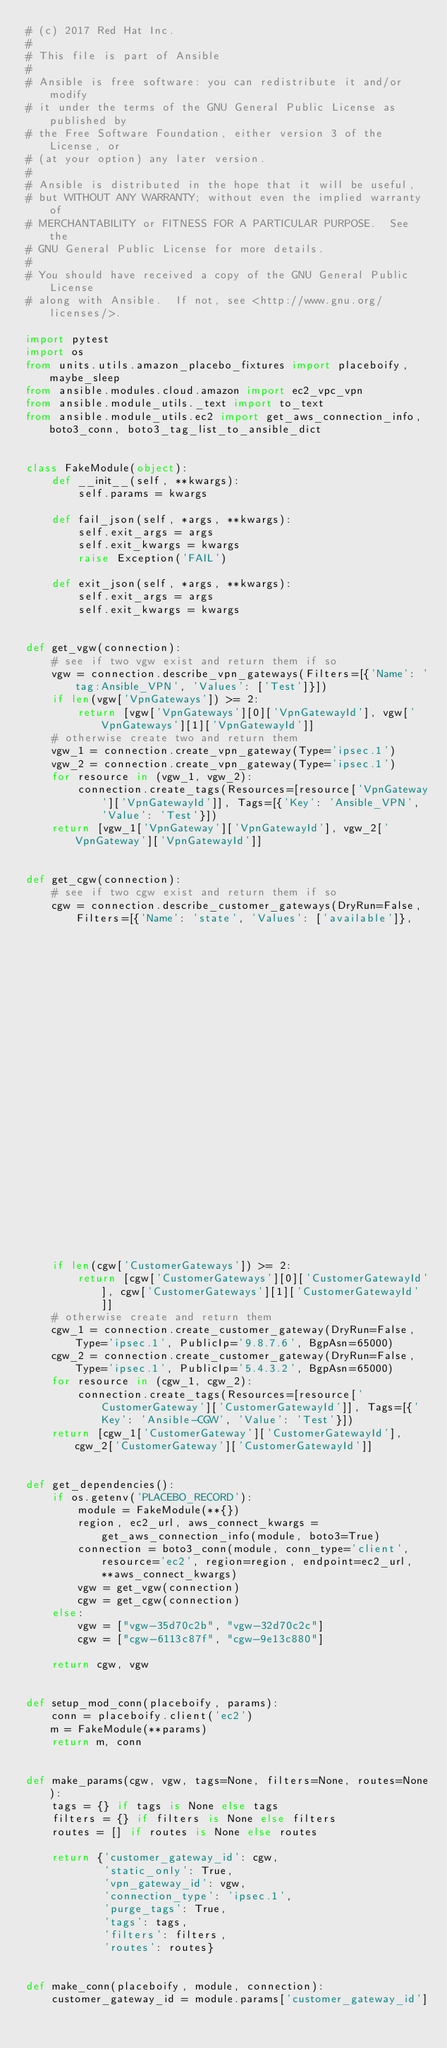Convert code to text. <code><loc_0><loc_0><loc_500><loc_500><_Python_># (c) 2017 Red Hat Inc.
#
# This file is part of Ansible
#
# Ansible is free software: you can redistribute it and/or modify
# it under the terms of the GNU General Public License as published by
# the Free Software Foundation, either version 3 of the License, or
# (at your option) any later version.
#
# Ansible is distributed in the hope that it will be useful,
# but WITHOUT ANY WARRANTY; without even the implied warranty of
# MERCHANTABILITY or FITNESS FOR A PARTICULAR PURPOSE.  See the
# GNU General Public License for more details.
#
# You should have received a copy of the GNU General Public License
# along with Ansible.  If not, see <http://www.gnu.org/licenses/>.

import pytest
import os
from units.utils.amazon_placebo_fixtures import placeboify, maybe_sleep
from ansible.modules.cloud.amazon import ec2_vpc_vpn
from ansible.module_utils._text import to_text
from ansible.module_utils.ec2 import get_aws_connection_info, boto3_conn, boto3_tag_list_to_ansible_dict


class FakeModule(object):
    def __init__(self, **kwargs):
        self.params = kwargs

    def fail_json(self, *args, **kwargs):
        self.exit_args = args
        self.exit_kwargs = kwargs
        raise Exception('FAIL')

    def exit_json(self, *args, **kwargs):
        self.exit_args = args
        self.exit_kwargs = kwargs


def get_vgw(connection):
    # see if two vgw exist and return them if so
    vgw = connection.describe_vpn_gateways(Filters=[{'Name': 'tag:Ansible_VPN', 'Values': ['Test']}])
    if len(vgw['VpnGateways']) >= 2:
        return [vgw['VpnGateways'][0]['VpnGatewayId'], vgw['VpnGateways'][1]['VpnGatewayId']]
    # otherwise create two and return them
    vgw_1 = connection.create_vpn_gateway(Type='ipsec.1')
    vgw_2 = connection.create_vpn_gateway(Type='ipsec.1')
    for resource in (vgw_1, vgw_2):
        connection.create_tags(Resources=[resource['VpnGateway']['VpnGatewayId']], Tags=[{'Key': 'Ansible_VPN', 'Value': 'Test'}])
    return [vgw_1['VpnGateway']['VpnGatewayId'], vgw_2['VpnGateway']['VpnGatewayId']]


def get_cgw(connection):
    # see if two cgw exist and return them if so
    cgw = connection.describe_customer_gateways(DryRun=False, Filters=[{'Name': 'state', 'Values': ['available']},
                                                                       {'Name': 'tag:Name', 'Values': ['Ansible-CGW']}])
    if len(cgw['CustomerGateways']) >= 2:
        return [cgw['CustomerGateways'][0]['CustomerGatewayId'], cgw['CustomerGateways'][1]['CustomerGatewayId']]
    # otherwise create and return them
    cgw_1 = connection.create_customer_gateway(DryRun=False, Type='ipsec.1', PublicIp='9.8.7.6', BgpAsn=65000)
    cgw_2 = connection.create_customer_gateway(DryRun=False, Type='ipsec.1', PublicIp='5.4.3.2', BgpAsn=65000)
    for resource in (cgw_1, cgw_2):
        connection.create_tags(Resources=[resource['CustomerGateway']['CustomerGatewayId']], Tags=[{'Key': 'Ansible-CGW', 'Value': 'Test'}])
    return [cgw_1['CustomerGateway']['CustomerGatewayId'], cgw_2['CustomerGateway']['CustomerGatewayId']]


def get_dependencies():
    if os.getenv('PLACEBO_RECORD'):
        module = FakeModule(**{})
        region, ec2_url, aws_connect_kwargs = get_aws_connection_info(module, boto3=True)
        connection = boto3_conn(module, conn_type='client', resource='ec2', region=region, endpoint=ec2_url, **aws_connect_kwargs)
        vgw = get_vgw(connection)
        cgw = get_cgw(connection)
    else:
        vgw = ["vgw-35d70c2b", "vgw-32d70c2c"]
        cgw = ["cgw-6113c87f", "cgw-9e13c880"]

    return cgw, vgw


def setup_mod_conn(placeboify, params):
    conn = placeboify.client('ec2')
    m = FakeModule(**params)
    return m, conn


def make_params(cgw, vgw, tags=None, filters=None, routes=None):
    tags = {} if tags is None else tags
    filters = {} if filters is None else filters
    routes = [] if routes is None else routes

    return {'customer_gateway_id': cgw,
            'static_only': True,
            'vpn_gateway_id': vgw,
            'connection_type': 'ipsec.1',
            'purge_tags': True,
            'tags': tags,
            'filters': filters,
            'routes': routes}


def make_conn(placeboify, module, connection):
    customer_gateway_id = module.params['customer_gateway_id']</code> 